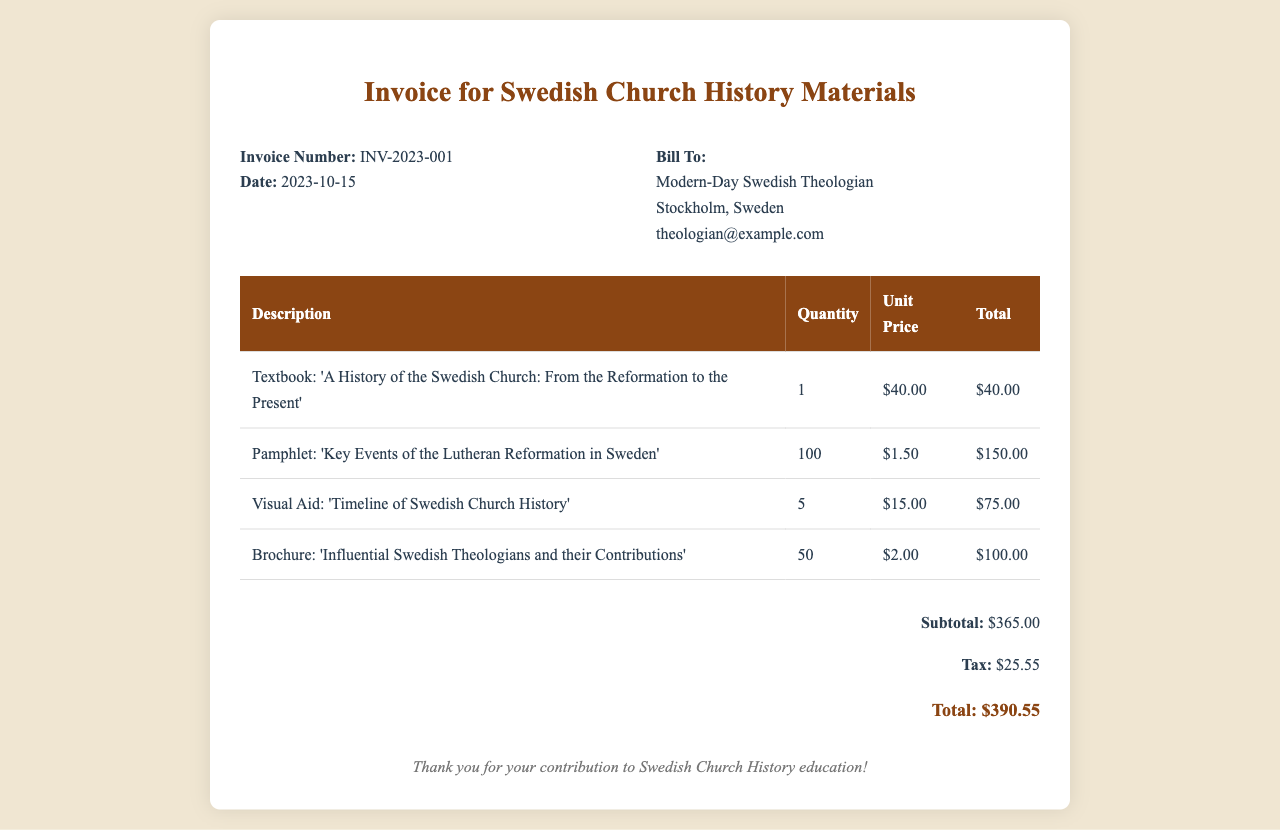What is the invoice number? The invoice number is listed clearly at the top of the document, identified as INV-2023-001.
Answer: INV-2023-001 What is the date of the invoice? The date of the invoice is provided next to the invoice number, which is 2023-10-15.
Answer: 2023-10-15 How much is the subtotal? The subtotal is specified in the total section of the invoice as $365.00.
Answer: $365.00 What is the tax amount? The tax amount is detailed in the total section as $25.55, reflecting the tax on the subtotal.
Answer: $25.55 What is the total amount due? The total amount due combines the subtotal and tax, which is stated as $390.55.
Answer: $390.55 How many pamphlets were ordered? The quantity of pamphlets ordered is mentioned in the table as 100.
Answer: 100 What is the unit price of the textbook? The unit price for the textbook is indicated in the table as $40.00.
Answer: $40.00 Which visual aid is included in the order? The document lists 'Timeline of Swedish Church History' as one of the visual aids included in the order.
Answer: Timeline of Swedish Church History What group is the invoice billed to? The billing information specifies that it is addressed to a Modern-Day Swedish Theologian.
Answer: Modern-Day Swedish Theologian 